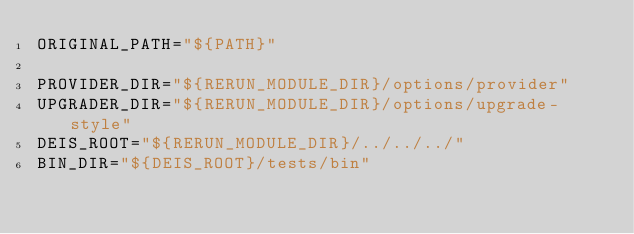<code> <loc_0><loc_0><loc_500><loc_500><_Bash_>ORIGINAL_PATH="${PATH}"

PROVIDER_DIR="${RERUN_MODULE_DIR}/options/provider"
UPGRADER_DIR="${RERUN_MODULE_DIR}/options/upgrade-style"
DEIS_ROOT="${RERUN_MODULE_DIR}/../../../"
BIN_DIR="${DEIS_ROOT}/tests/bin"</code> 